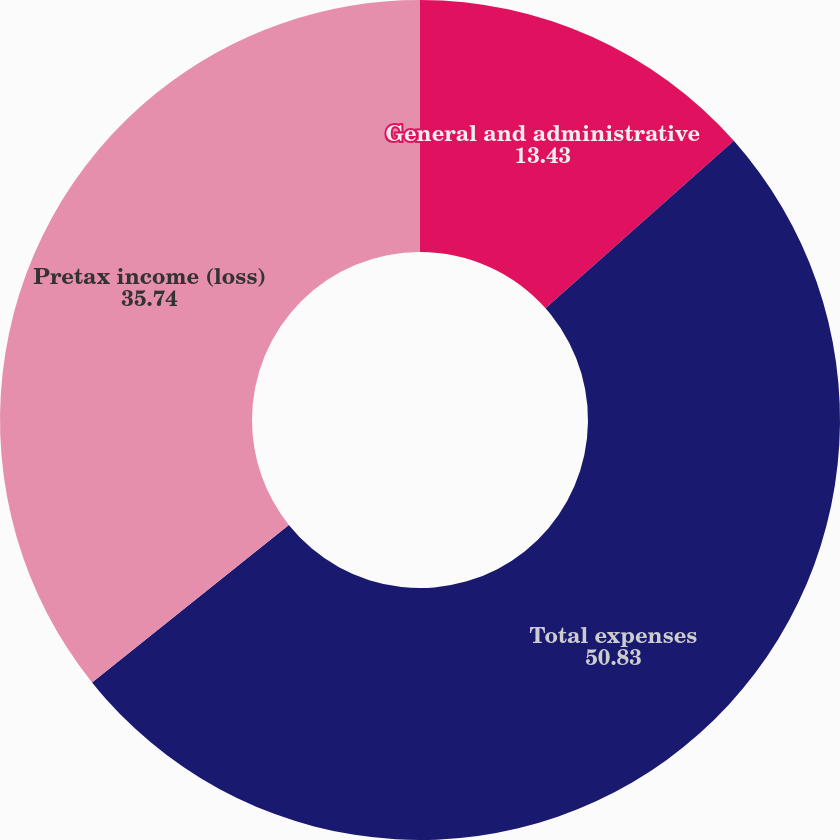Convert chart. <chart><loc_0><loc_0><loc_500><loc_500><pie_chart><fcel>General and administrative<fcel>Total expenses<fcel>Pretax income (loss)<nl><fcel>13.43%<fcel>50.83%<fcel>35.74%<nl></chart> 